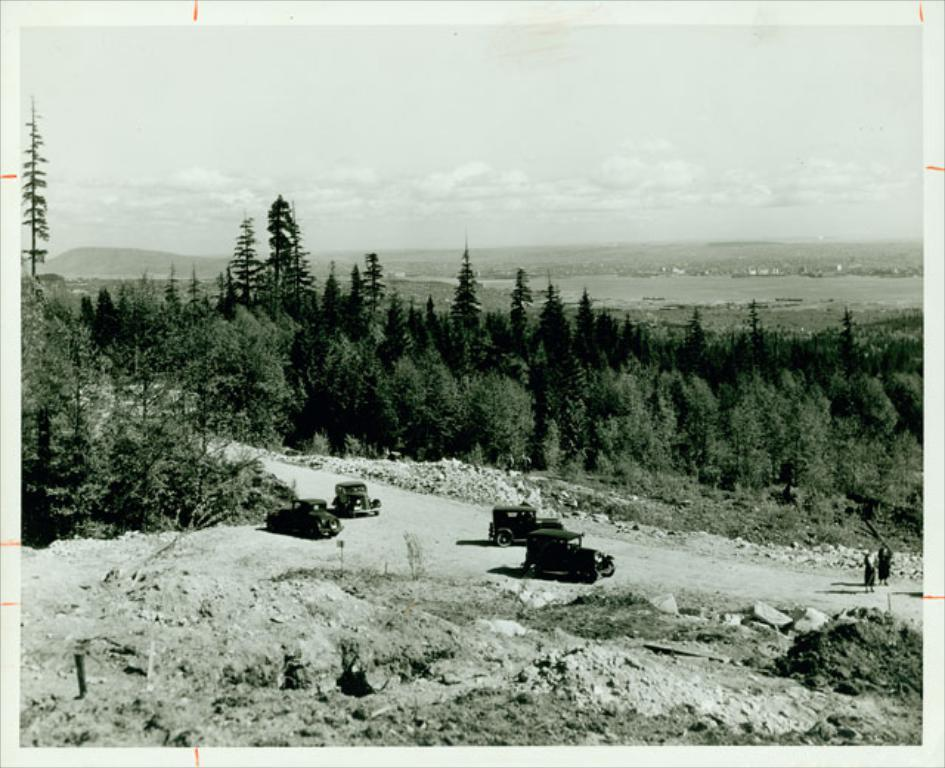What type of vehicles can be seen in the image? There are cars in the image. What type of natural vegetation is visible in the image? There are trees in the image. What type of living organisms can be seen in the image? There are people in the image. What is the condition of the sky in the image? The sky is cloudy in the image. Can you tell me how many brothers are depicted in the image? There is no reference to a brother in the image, so it is not possible to answer that question. What type of bubble can be seen floating in the image? There is no bubble present in the image. 